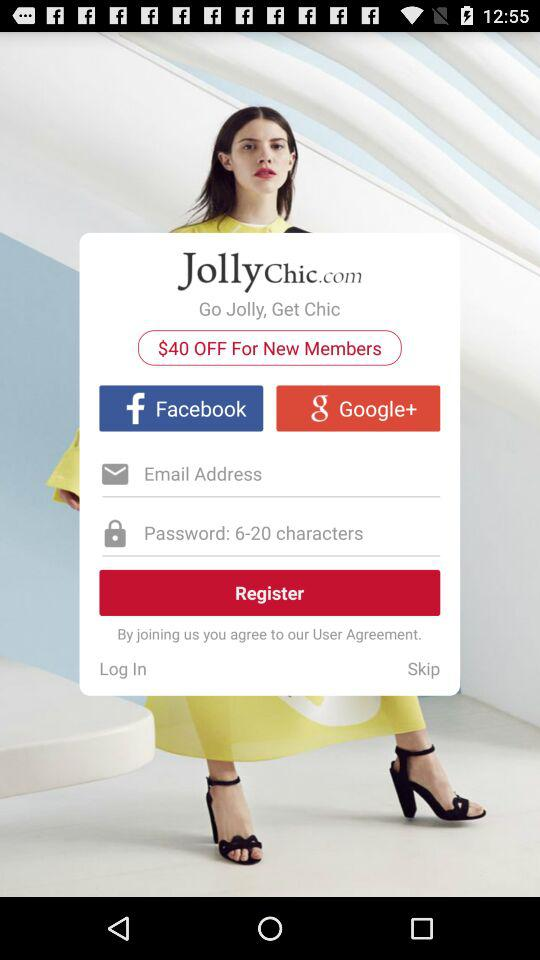Which applications can be used to register? The applications that can be used to register are "Facebook" and "Google+". 